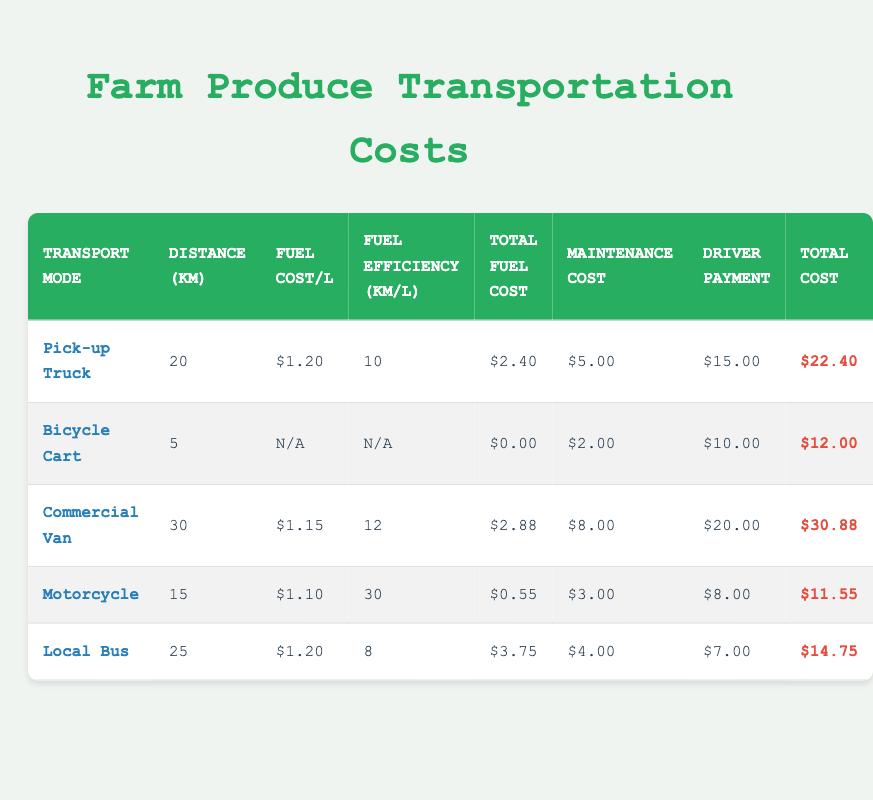What is the total transportation cost for using a Pick-up Truck? The total transportation cost for a Pick-up Truck is provided directly under the "Total Cost" column, which shows $22.40.
Answer: 22.40 How far does a Commercial Van travel? The distance for a Commercial Van is indicated in the "Distance (km)" column, which states it travels 30 km.
Answer: 30 km Which transport mode has the highest total transportation cost? By examining the "Total Cost" column, the Commercial Van shows the highest value at $30.88.
Answer: Commercial Van What is the average total transportation cost across all modes? First, sum the total costs: 22.40 + 12.00 + 30.88 + 11.55 + 14.75 = 91.58, then divide by the number of modes, which is 5. Thus, average cost = 91.58 / 5 = 18.316.
Answer: 18.316 Does the Bicycle Cart have a fuel cost associated with its transportation? Looking at the "Fuel Cost/L" column for the Bicycle Cart, it is marked as N/A, indicating there is no fuel cost for this transport.
Answer: Yes What is the total maintenance cost for all transport modes combined? Adding the maintenance costs: 5.00 + 2.00 + 8.00 + 3.00 + 4.00 = 22.00 gives the total maintenance cost for all modes.
Answer: 22.00 Is it true that the Motorcycle has the lowest total transportation cost? Checking the total costs, the Motorcycle has $11.55, while others have higher costs, confirming that it is indeed the lowest.
Answer: True How much does it cost to transport produce using a Local Bus compared to a Motorcycle? The Local Bus costs $14.75, while the Motorcycle costs $11.55. Subtracting these gives $14.75 - $11.55 = $3.20, indicating Local Bus is $3.20 more expensive.
Answer: Local Bus is $3.20 more expensive What is the difference in distance between the Bicycle Cart and the Commercial Van? The distance of the Bicycle Cart is 5 km, and for the Commercial Van, it is 30 km. The difference is 30 km - 5 km = 25 km.
Answer: 25 km 